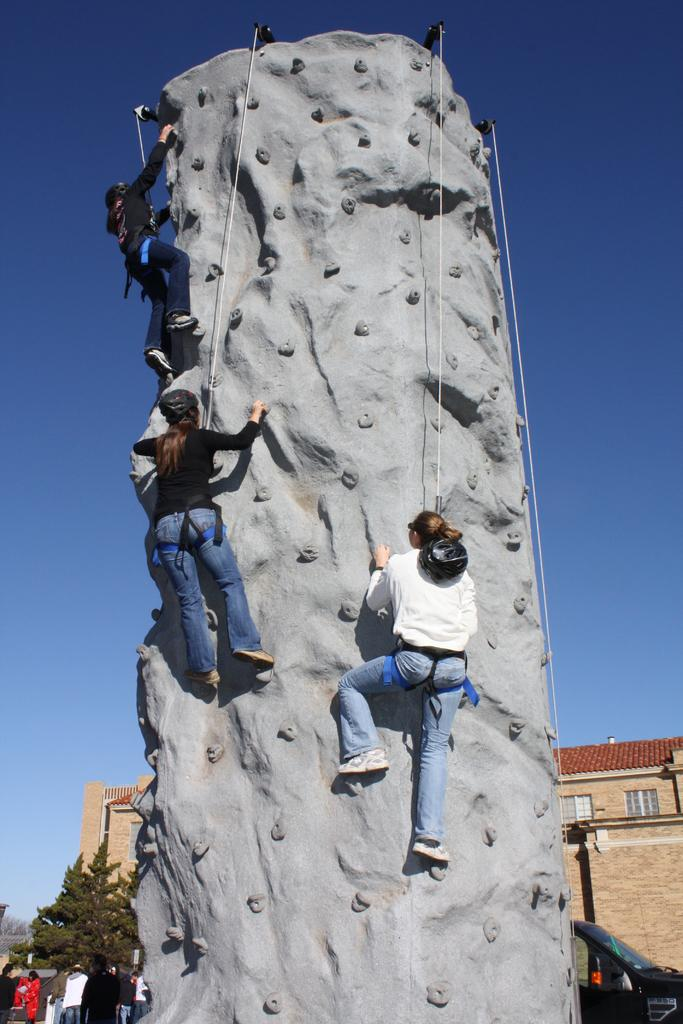What are the three people in the image doing? The three people are climbing a wall. What can be seen behind the wall? There is a vehicle, a tree, buildings, and people standing behind the wall. What is visible in the sky in the image? The sky is visible in the image. What type of ear can be seen on the tree behind the wall? There are no ears present in the image, as it features people climbing a wall and objects behind the wall. 